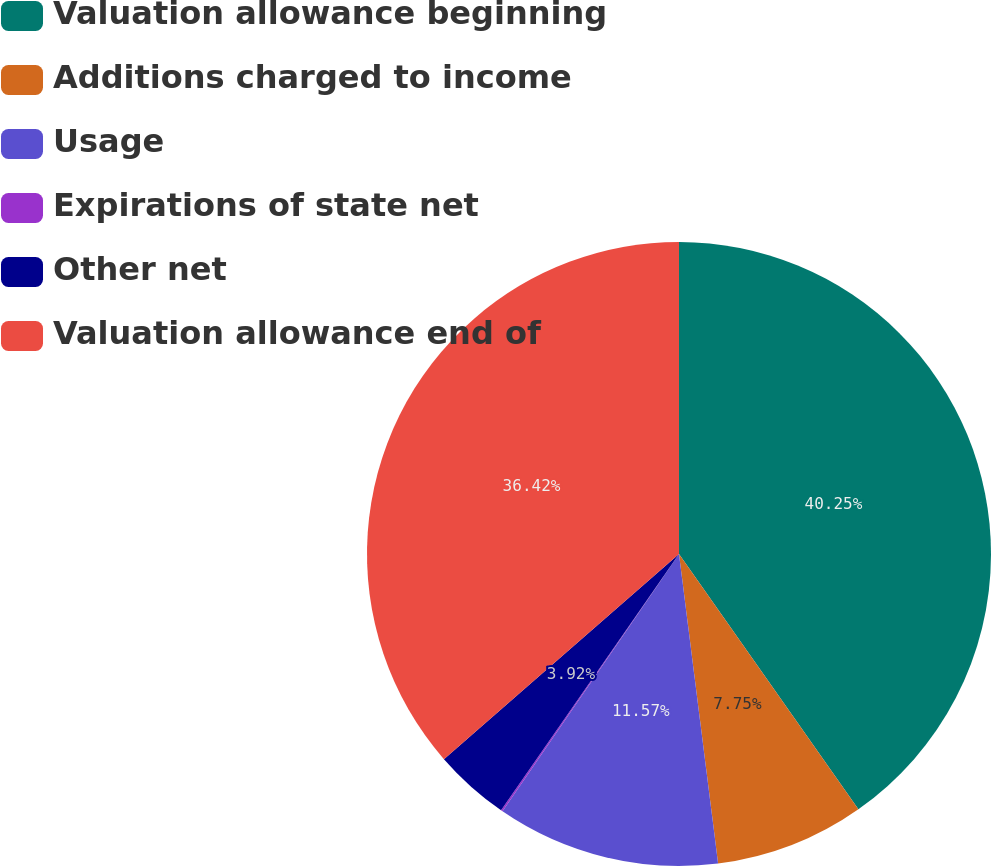<chart> <loc_0><loc_0><loc_500><loc_500><pie_chart><fcel>Valuation allowance beginning<fcel>Additions charged to income<fcel>Usage<fcel>Expirations of state net<fcel>Other net<fcel>Valuation allowance end of<nl><fcel>40.25%<fcel>7.75%<fcel>11.57%<fcel>0.09%<fcel>3.92%<fcel>36.42%<nl></chart> 